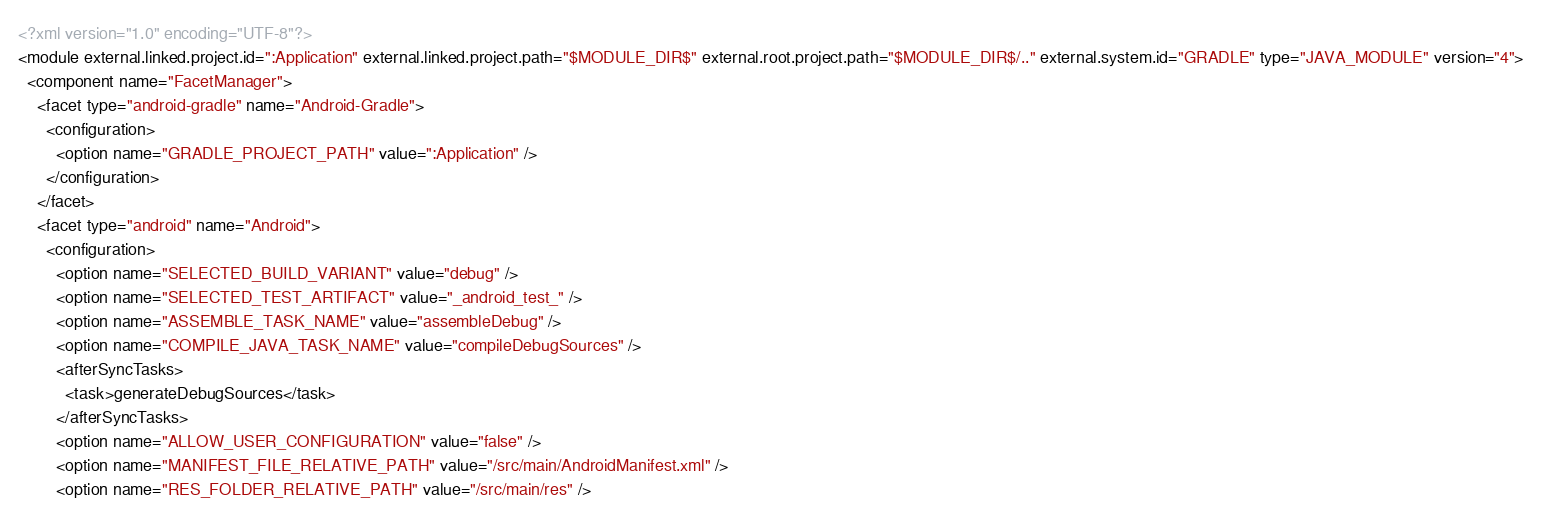Convert code to text. <code><loc_0><loc_0><loc_500><loc_500><_XML_><?xml version="1.0" encoding="UTF-8"?>
<module external.linked.project.id=":Application" external.linked.project.path="$MODULE_DIR$" external.root.project.path="$MODULE_DIR$/.." external.system.id="GRADLE" type="JAVA_MODULE" version="4">
  <component name="FacetManager">
    <facet type="android-gradle" name="Android-Gradle">
      <configuration>
        <option name="GRADLE_PROJECT_PATH" value=":Application" />
      </configuration>
    </facet>
    <facet type="android" name="Android">
      <configuration>
        <option name="SELECTED_BUILD_VARIANT" value="debug" />
        <option name="SELECTED_TEST_ARTIFACT" value="_android_test_" />
        <option name="ASSEMBLE_TASK_NAME" value="assembleDebug" />
        <option name="COMPILE_JAVA_TASK_NAME" value="compileDebugSources" />
        <afterSyncTasks>
          <task>generateDebugSources</task>
        </afterSyncTasks>
        <option name="ALLOW_USER_CONFIGURATION" value="false" />
        <option name="MANIFEST_FILE_RELATIVE_PATH" value="/src/main/AndroidManifest.xml" />
        <option name="RES_FOLDER_RELATIVE_PATH" value="/src/main/res" /></code> 